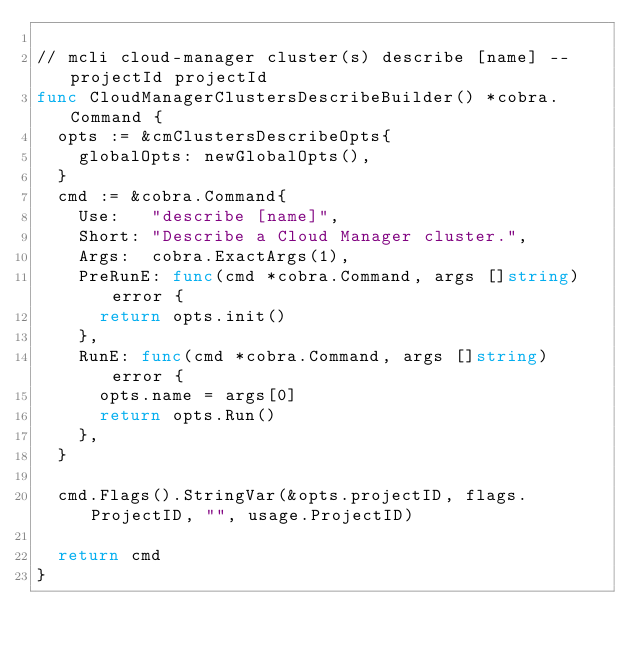<code> <loc_0><loc_0><loc_500><loc_500><_Go_>
// mcli cloud-manager cluster(s) describe [name] --projectId projectId
func CloudManagerClustersDescribeBuilder() *cobra.Command {
	opts := &cmClustersDescribeOpts{
		globalOpts: newGlobalOpts(),
	}
	cmd := &cobra.Command{
		Use:   "describe [name]",
		Short: "Describe a Cloud Manager cluster.",
		Args:  cobra.ExactArgs(1),
		PreRunE: func(cmd *cobra.Command, args []string) error {
			return opts.init()
		},
		RunE: func(cmd *cobra.Command, args []string) error {
			opts.name = args[0]
			return opts.Run()
		},
	}

	cmd.Flags().StringVar(&opts.projectID, flags.ProjectID, "", usage.ProjectID)

	return cmd
}
</code> 